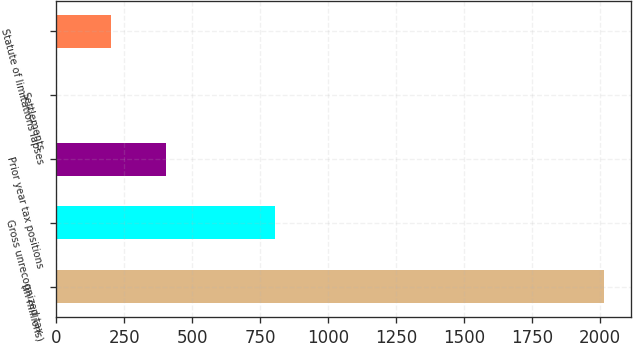Convert chart. <chart><loc_0><loc_0><loc_500><loc_500><bar_chart><fcel>(in millions)<fcel>Gross unrecognized tax<fcel>Prior year tax positions<fcel>Settlements<fcel>Statute of limitations lapses<nl><fcel>2015<fcel>806.6<fcel>403.8<fcel>1<fcel>202.4<nl></chart> 